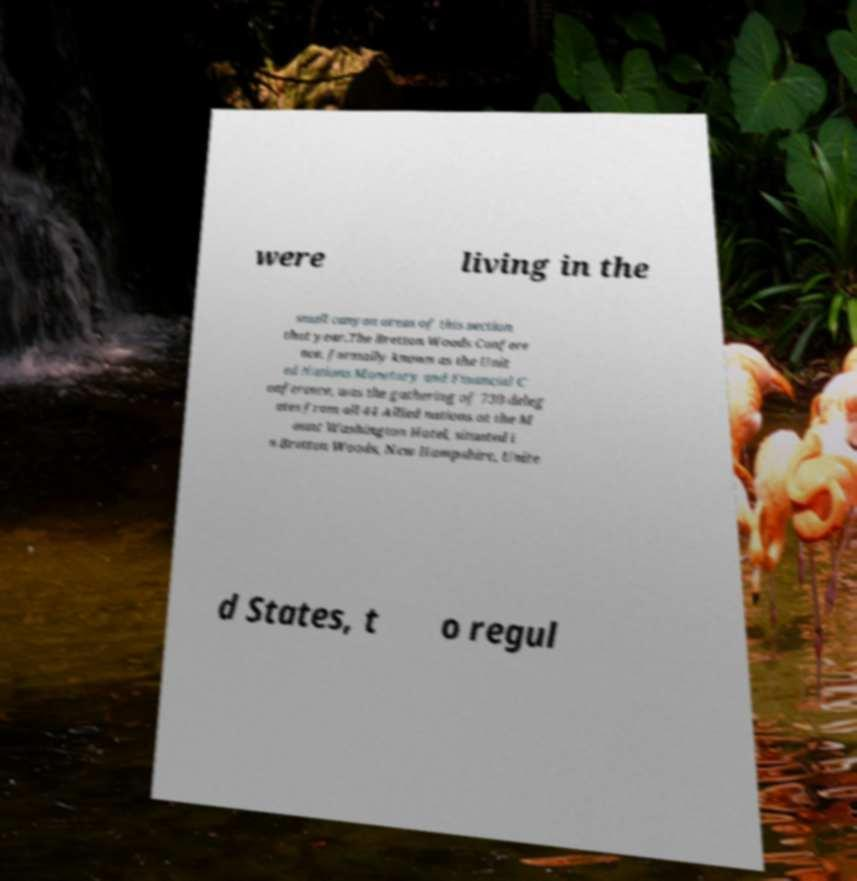For documentation purposes, I need the text within this image transcribed. Could you provide that? were living in the small canyon areas of this section that year.The Bretton Woods Confere nce, formally known as the Unit ed Nations Monetary and Financial C onference, was the gathering of 730 deleg ates from all 44 Allied nations at the M ount Washington Hotel, situated i n Bretton Woods, New Hampshire, Unite d States, t o regul 